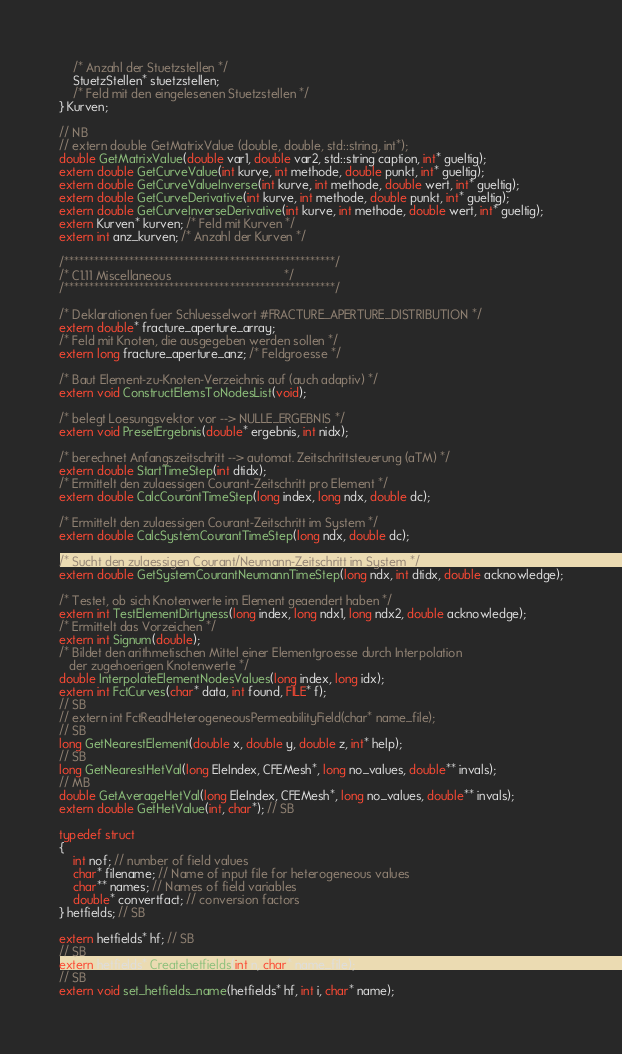<code> <loc_0><loc_0><loc_500><loc_500><_C_>	/* Anzahl der Stuetzstellen */
	StuetzStellen* stuetzstellen;
	/* Feld mit den eingelesenen Stuetzstellen */
} Kurven;

// NB
// extern double GetMatrixValue (double, double, std::string, int*);
double GetMatrixValue(double var1, double var2, std::string caption, int* gueltig);
extern double GetCurveValue(int kurve, int methode, double punkt, int* gueltig);
extern double GetCurveValueInverse(int kurve, int methode, double wert, int* gueltig);
extern double GetCurveDerivative(int kurve, int methode, double punkt, int* gueltig);
extern double GetCurveInverseDerivative(int kurve, int methode, double wert, int* gueltig);
extern Kurven* kurven; /* Feld mit Kurven */
extern int anz_kurven; /* Anzahl der Kurven */

/******************************************************/
/* C1.11 Miscellaneous                                 */
/******************************************************/

/* Deklarationen fuer Schluesselwort #FRACTURE_APERTURE_DISTRIBUTION */
extern double* fracture_aperture_array;
/* Feld mit Knoten, die ausgegeben werden sollen */
extern long fracture_aperture_anz; /* Feldgroesse */

/* Baut Element-zu-Knoten-Verzeichnis auf (auch adaptiv) */
extern void ConstructElemsToNodesList(void);

/* belegt Loesungsvektor vor --> NULLE_ERGEBNIS */
extern void PresetErgebnis(double* ergebnis, int nidx);

/* berechnet Anfangszeitschritt --> automat. Zeitschrittsteuerung (aTM) */
extern double StartTimeStep(int dtidx);
/* Ermittelt den zulaessigen Courant-Zeitschritt pro Element */
extern double CalcCourantTimeStep(long index, long ndx, double dc);

/* Ermittelt den zulaessigen Courant-Zeitschritt im System */
extern double CalcSystemCourantTimeStep(long ndx, double dc);

/* Sucht den zulaessigen Courant/Neumann-Zeitschritt im System */
extern double GetSystemCourantNeumannTimeStep(long ndx, int dtidx, double acknowledge);

/* Testet, ob sich Knotenwerte im Element geaendert haben */
extern int TestElementDirtyness(long index, long ndx1, long ndx2, double acknowledge);
/* Ermittelt das Vorzeichen */
extern int Signum(double);
/* Bildet den arithmetischen Mittel einer Elementgroesse durch Interpolation
   der zugehoerigen Knotenwerte */
double InterpolateElementNodesValues(long index, long idx);
extern int FctCurves(char* data, int found, FILE* f);
// SB
// extern int FctReadHeterogeneousPermeabilityField(char* name_file);
// SB
long GetNearestElement(double x, double y, double z, int* help);
// SB
long GetNearestHetVal(long EleIndex, CFEMesh*, long no_values, double** invals);
// MB
double GetAverageHetVal(long EleIndex, CFEMesh*, long no_values, double** invals);
extern double GetHetValue(int, char*); // SB

typedef struct
{
	int nof; // number of field values
	char* filename; // Name of input file for heterogeneous values
	char** names; // Names of field variables
	double* convertfact; // conversion factors
} hetfields; // SB

extern hetfields* hf; // SB
// SB
extern hetfields* Createhetfields(int n, char* name_file);
// SB
extern void set_hetfields_name(hetfields* hf, int i, char* name);</code> 